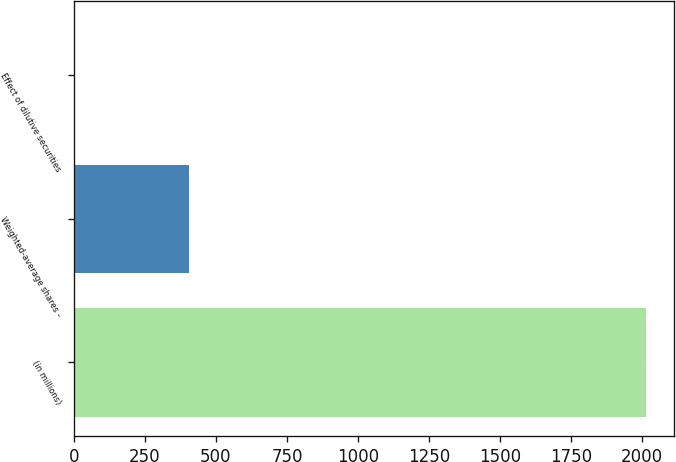Convert chart. <chart><loc_0><loc_0><loc_500><loc_500><bar_chart><fcel>(in millions)<fcel>Weighted-average shares -<fcel>Effect of dilutive securities<nl><fcel>2013<fcel>404.28<fcel>2.1<nl></chart> 